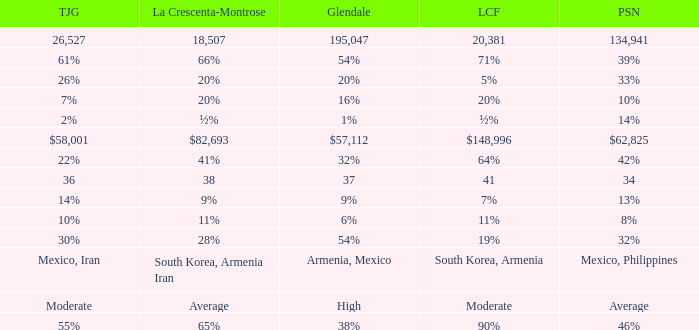What is the percentage of Tujunja when Pasadena is 33%? 26%. 